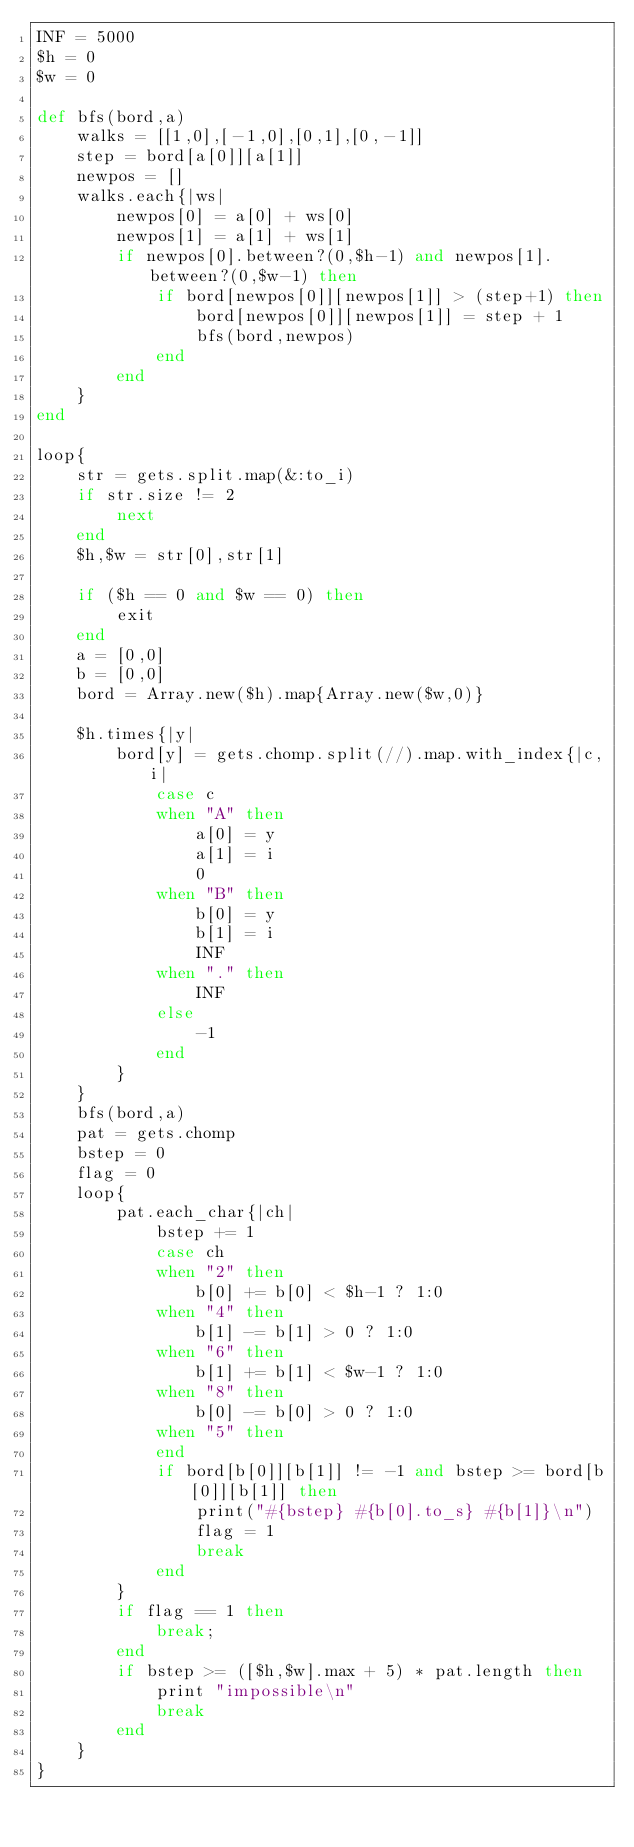Convert code to text. <code><loc_0><loc_0><loc_500><loc_500><_Ruby_>INF = 5000
$h = 0
$w = 0

def bfs(bord,a)
	walks = [[1,0],[-1,0],[0,1],[0,-1]]
	step = bord[a[0]][a[1]]
	newpos = []
	walks.each{|ws|
		newpos[0] = a[0] + ws[0]
		newpos[1] = a[1] + ws[1]
		if newpos[0].between?(0,$h-1) and newpos[1].between?(0,$w-1) then
			if bord[newpos[0]][newpos[1]] > (step+1) then
				bord[newpos[0]][newpos[1]] = step + 1
				bfs(bord,newpos)
			end
		end
	}
end

loop{
	str = gets.split.map(&:to_i)
    if str.size != 2
        next
    end
    $h,$w = str[0],str[1]

	if ($h == 0 and $w == 0) then
		exit
	end
	a = [0,0]
	b = [0,0]
	bord = Array.new($h).map{Array.new($w,0)}

	$h.times{|y|	
		bord[y] = gets.chomp.split(//).map.with_index{|c,i|
			case c
			when "A" then
				a[0] = y
				a[1] = i
				0
			when "B" then
				b[0] = y
				b[1] = i
				INF
			when "." then
				INF
			else
				-1
			end
		}
	}
	bfs(bord,a)
	pat = gets.chomp
	bstep = 0
	flag = 0
	loop{
		pat.each_char{|ch|
			bstep += 1
			case ch
			when "2" then
				b[0] += b[0] < $h-1 ? 1:0
			when "4" then
				b[1] -= b[1] > 0 ? 1:0
			when "6" then
				b[1] += b[1] < $w-1 ? 1:0
			when "8" then
				b[0] -= b[0] > 0 ? 1:0
			when "5" then
			end
			if bord[b[0]][b[1]] != -1 and bstep >= bord[b[0]][b[1]] then
				print("#{bstep} #{b[0].to_s} #{b[1]}\n")
				flag = 1
				break
			end
		}
		if flag == 1 then
			break;
		end
		if bstep >= ([$h,$w].max + 5) * pat.length then
			print "impossible\n"
			break
		end
	}
}</code> 